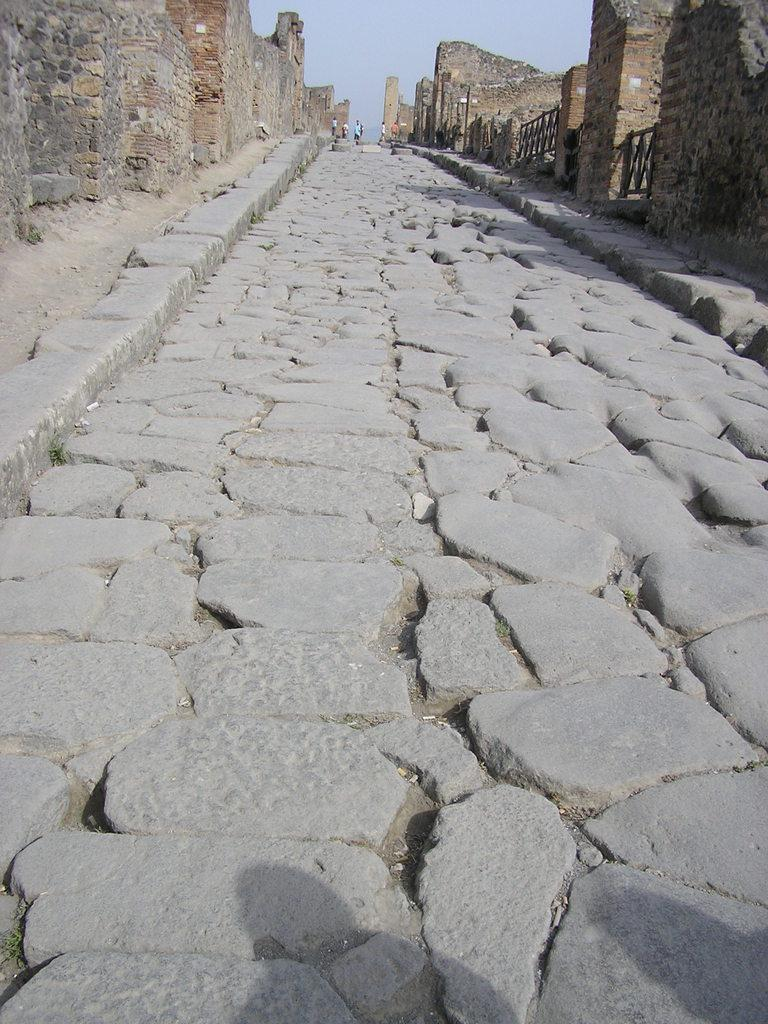What type of path is in the foreground of the image? There is a stone path in the foreground of the image. What structures are on either side of the path? There are walls on either side of the path. Are there any additional features on the right side of the path? Yes, there are railings on the right side of the path. What can be seen in the background of the image? There are people visible in the background of the image, as well as the sky. What type of hospital can be seen in the image? There is no hospital present in the image. How does the person in the image control the weather? There is no person controlling the weather in the image; the sky is visible in the background, but no one is shown manipulating it. 